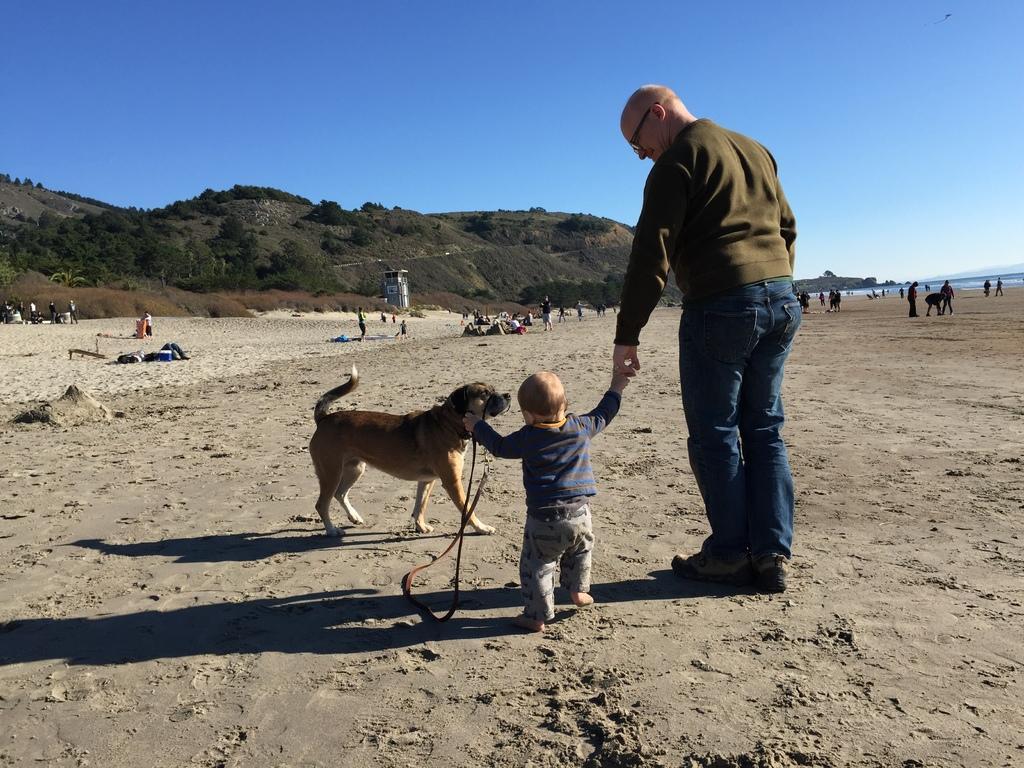In one or two sentences, can you explain what this image depicts? Man and a child standing with dog,here there is mountain and trees. 